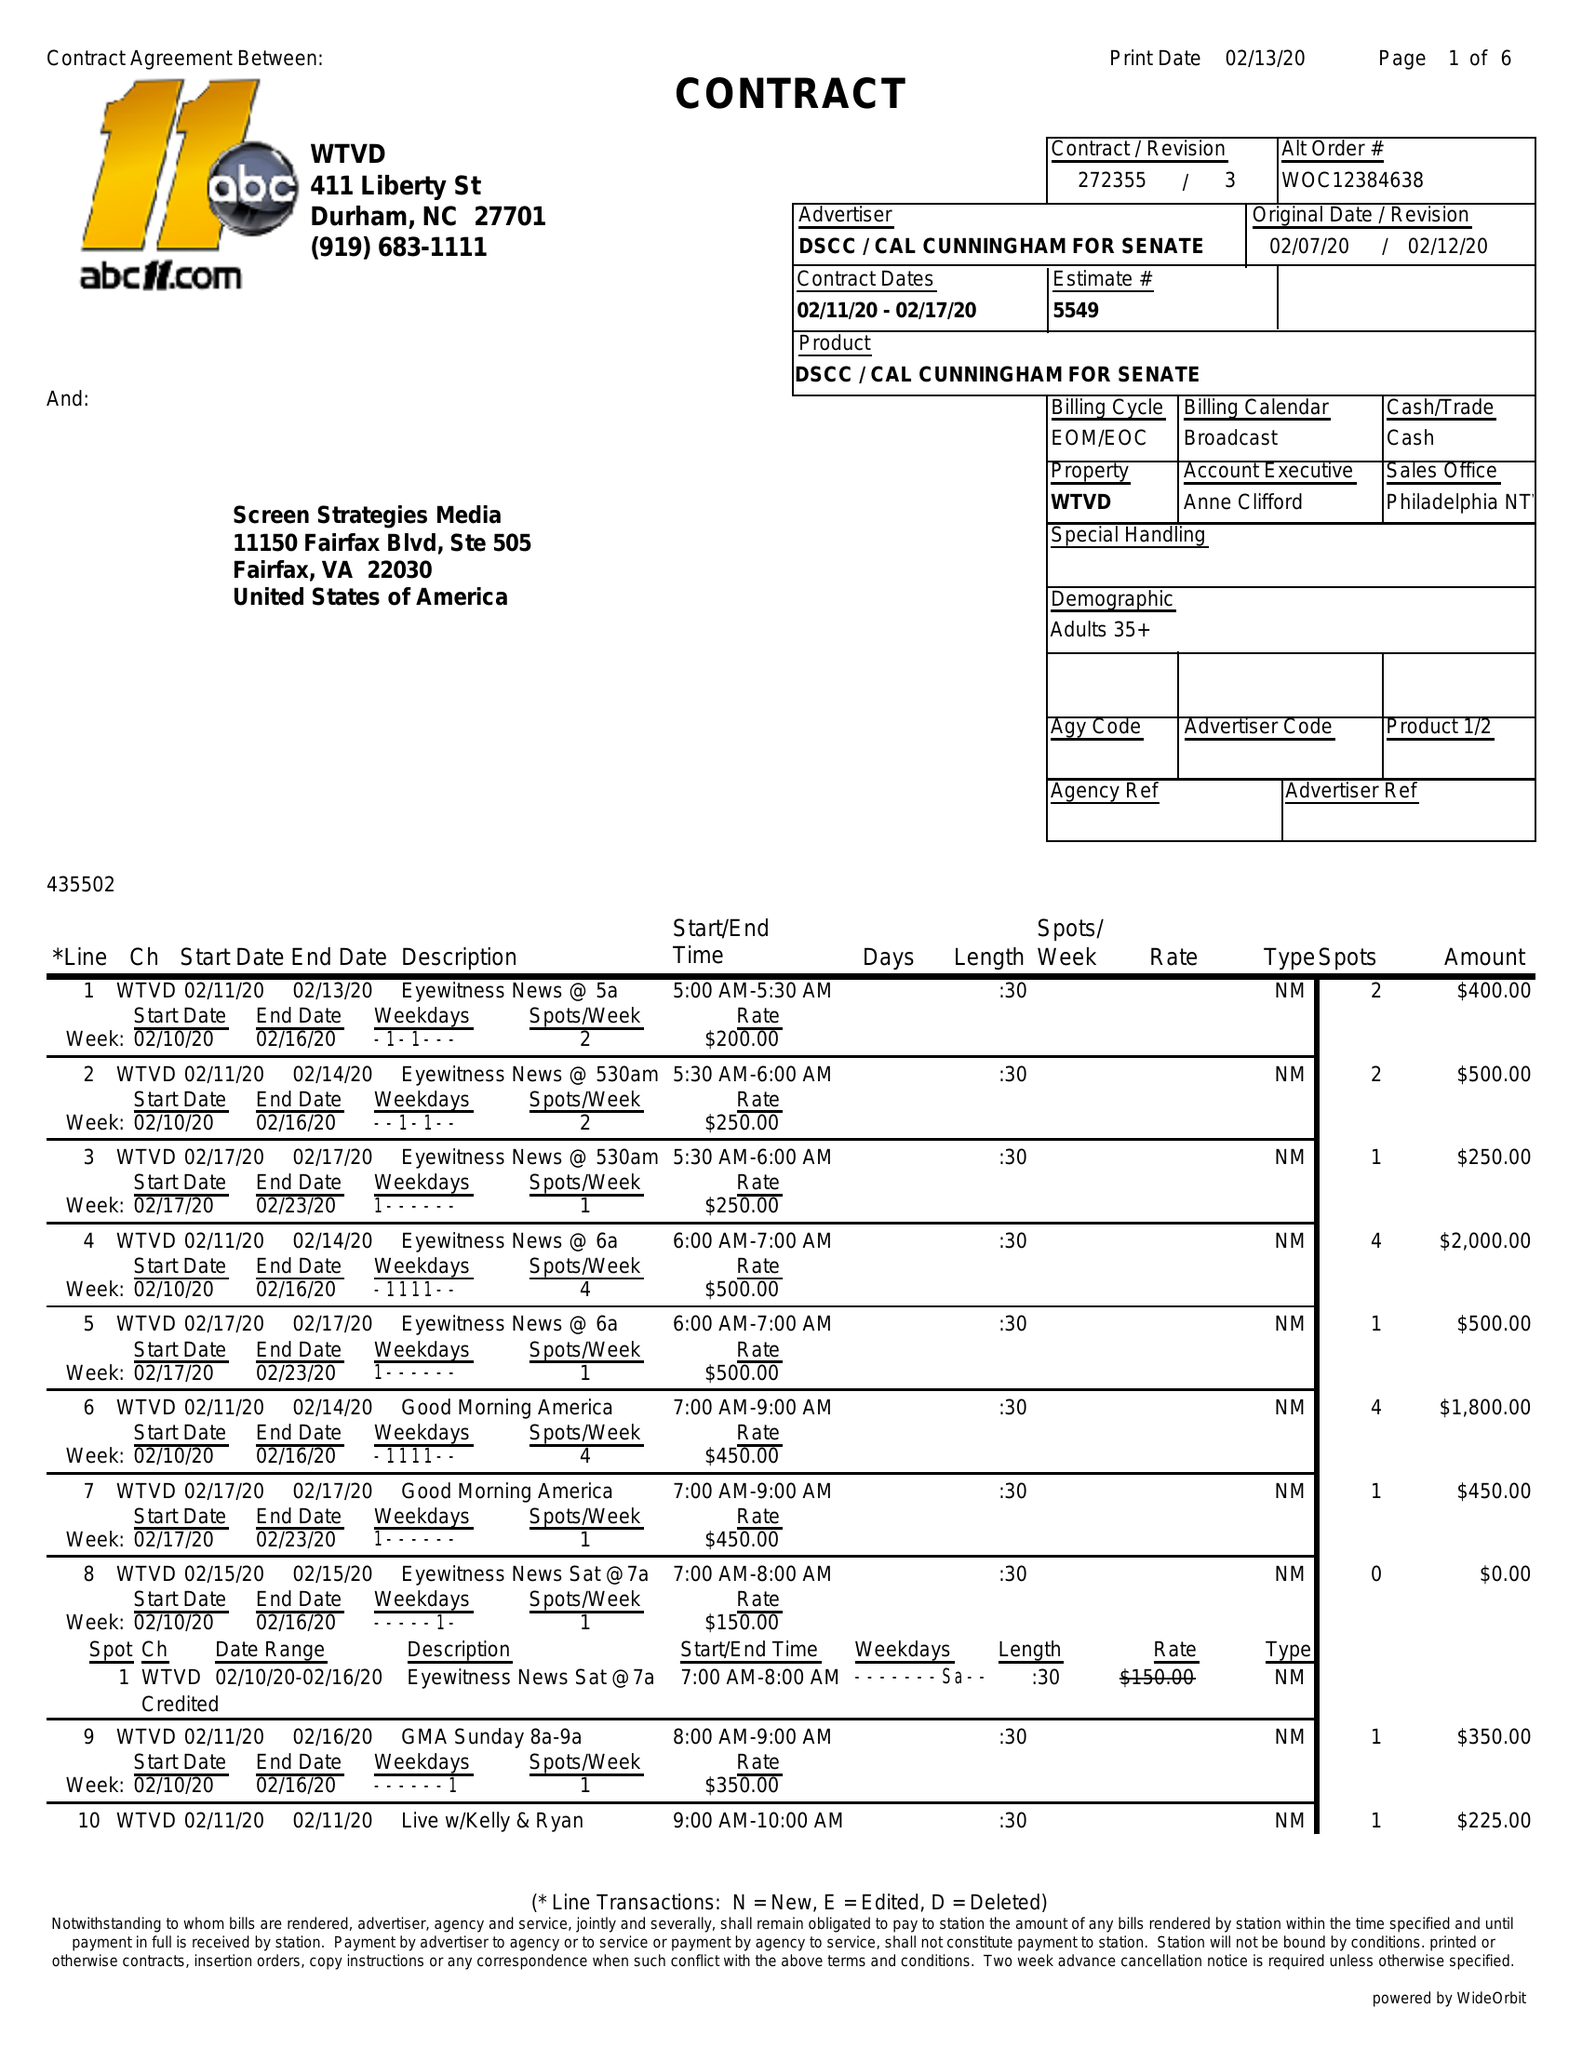What is the value for the advertiser?
Answer the question using a single word or phrase. DSCC/CALCUNNINGHAMFORSENATE 